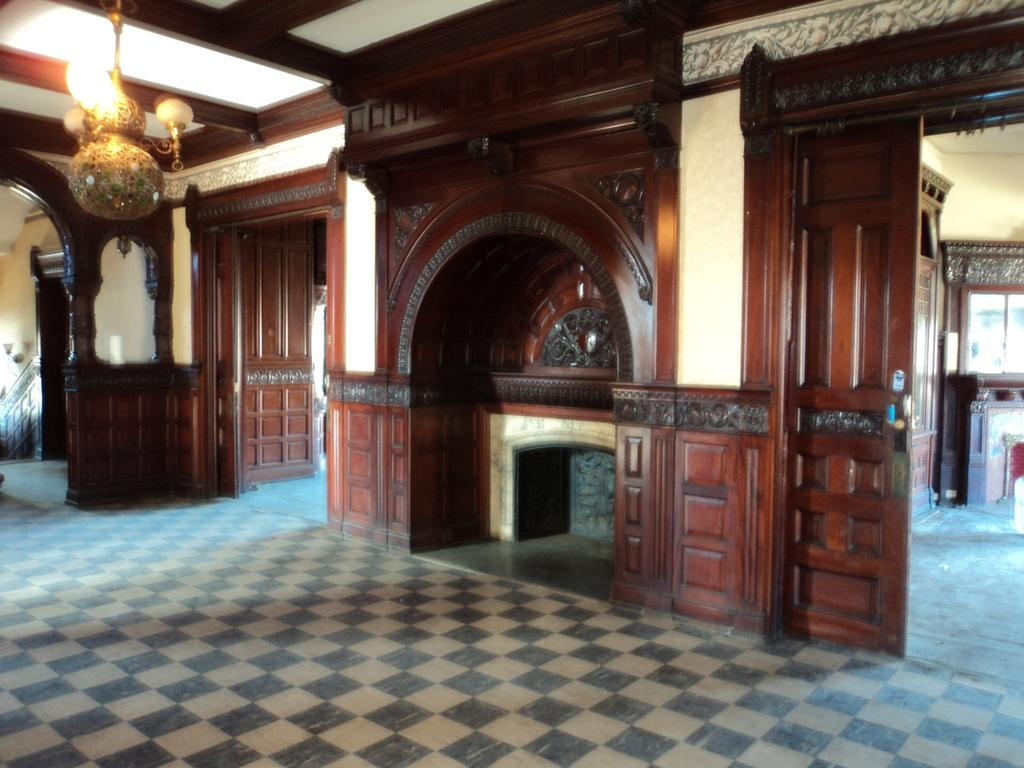What architectural feature is present in the image? There is a door in the image. What part of the building can be seen at the bottom of the image? The floor is visible at the bottom of the image. What part of the building can be seen at the top of the image? The roof is visible at the top of the image. What type of machine is making noise in the image? There is no machine or noise present in the image. Is there a battle taking place in the image? There is no battle or any indication of conflict in the image. 